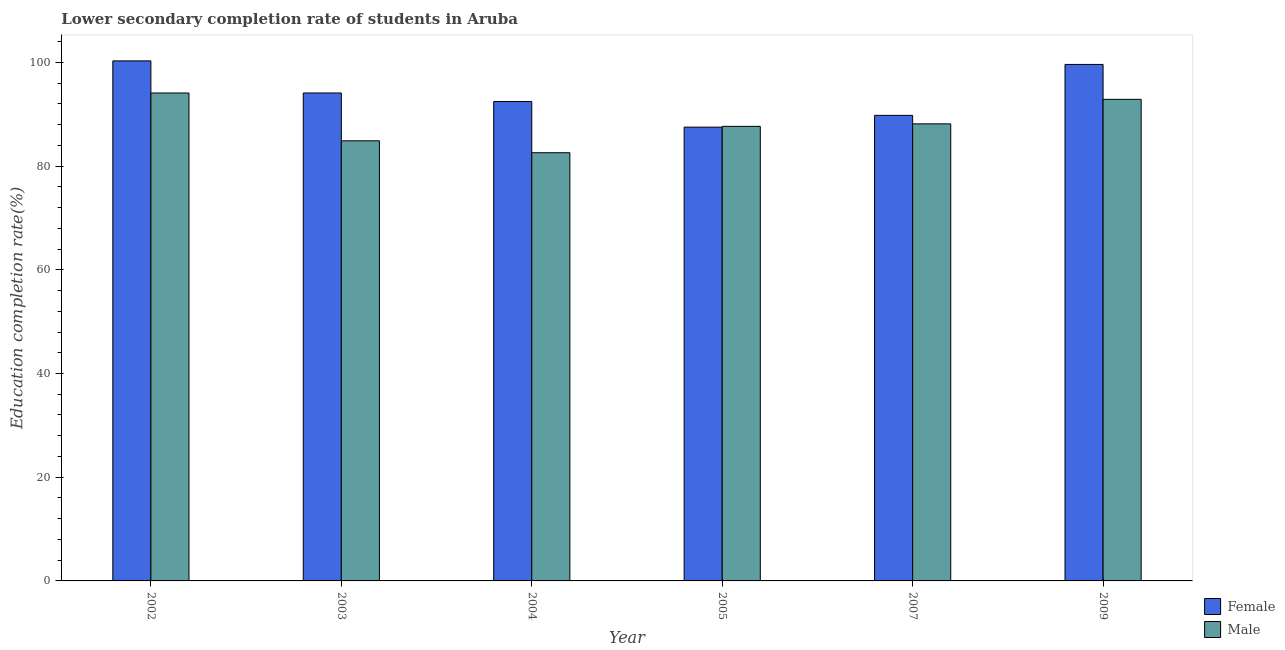How many different coloured bars are there?
Keep it short and to the point. 2. How many groups of bars are there?
Provide a succinct answer. 6. Are the number of bars per tick equal to the number of legend labels?
Provide a succinct answer. Yes. What is the education completion rate of female students in 2004?
Ensure brevity in your answer.  92.45. Across all years, what is the maximum education completion rate of female students?
Provide a short and direct response. 100.29. Across all years, what is the minimum education completion rate of male students?
Make the answer very short. 82.58. In which year was the education completion rate of male students maximum?
Your answer should be very brief. 2002. What is the total education completion rate of female students in the graph?
Keep it short and to the point. 563.76. What is the difference between the education completion rate of male students in 2002 and that in 2005?
Provide a short and direct response. 6.43. What is the difference between the education completion rate of male students in 2005 and the education completion rate of female students in 2003?
Ensure brevity in your answer.  2.79. What is the average education completion rate of female students per year?
Provide a short and direct response. 93.96. In the year 2009, what is the difference between the education completion rate of male students and education completion rate of female students?
Ensure brevity in your answer.  0. What is the ratio of the education completion rate of female students in 2003 to that in 2005?
Make the answer very short. 1.08. Is the education completion rate of female students in 2004 less than that in 2007?
Ensure brevity in your answer.  No. Is the difference between the education completion rate of male students in 2004 and 2007 greater than the difference between the education completion rate of female students in 2004 and 2007?
Keep it short and to the point. No. What is the difference between the highest and the second highest education completion rate of female students?
Your answer should be very brief. 0.69. What is the difference between the highest and the lowest education completion rate of female students?
Your response must be concise. 12.78. Is the sum of the education completion rate of male students in 2004 and 2005 greater than the maximum education completion rate of female students across all years?
Your answer should be compact. Yes. How many bars are there?
Your response must be concise. 12. Are all the bars in the graph horizontal?
Your response must be concise. No. Are the values on the major ticks of Y-axis written in scientific E-notation?
Your response must be concise. No. Where does the legend appear in the graph?
Offer a very short reply. Bottom right. What is the title of the graph?
Provide a succinct answer. Lower secondary completion rate of students in Aruba. What is the label or title of the Y-axis?
Provide a succinct answer. Education completion rate(%). What is the Education completion rate(%) in Female in 2002?
Provide a succinct answer. 100.29. What is the Education completion rate(%) of Male in 2002?
Offer a very short reply. 94.1. What is the Education completion rate(%) of Female in 2003?
Provide a succinct answer. 94.1. What is the Education completion rate(%) in Male in 2003?
Your answer should be very brief. 84.88. What is the Education completion rate(%) in Female in 2004?
Offer a very short reply. 92.45. What is the Education completion rate(%) of Male in 2004?
Provide a succinct answer. 82.58. What is the Education completion rate(%) of Female in 2005?
Give a very brief answer. 87.52. What is the Education completion rate(%) of Male in 2005?
Make the answer very short. 87.67. What is the Education completion rate(%) of Female in 2007?
Provide a short and direct response. 89.79. What is the Education completion rate(%) of Male in 2007?
Provide a succinct answer. 88.15. What is the Education completion rate(%) in Female in 2009?
Provide a short and direct response. 99.61. What is the Education completion rate(%) in Male in 2009?
Give a very brief answer. 92.88. Across all years, what is the maximum Education completion rate(%) in Female?
Offer a very short reply. 100.29. Across all years, what is the maximum Education completion rate(%) of Male?
Your answer should be very brief. 94.1. Across all years, what is the minimum Education completion rate(%) of Female?
Offer a terse response. 87.52. Across all years, what is the minimum Education completion rate(%) of Male?
Your answer should be compact. 82.58. What is the total Education completion rate(%) of Female in the graph?
Offer a very short reply. 563.75. What is the total Education completion rate(%) of Male in the graph?
Offer a very short reply. 530.25. What is the difference between the Education completion rate(%) of Female in 2002 and that in 2003?
Provide a succinct answer. 6.19. What is the difference between the Education completion rate(%) in Male in 2002 and that in 2003?
Provide a short and direct response. 9.22. What is the difference between the Education completion rate(%) of Female in 2002 and that in 2004?
Make the answer very short. 7.84. What is the difference between the Education completion rate(%) in Male in 2002 and that in 2004?
Your response must be concise. 11.52. What is the difference between the Education completion rate(%) in Female in 2002 and that in 2005?
Keep it short and to the point. 12.78. What is the difference between the Education completion rate(%) of Male in 2002 and that in 2005?
Give a very brief answer. 6.43. What is the difference between the Education completion rate(%) in Female in 2002 and that in 2007?
Provide a short and direct response. 10.51. What is the difference between the Education completion rate(%) of Male in 2002 and that in 2007?
Make the answer very short. 5.95. What is the difference between the Education completion rate(%) in Female in 2002 and that in 2009?
Provide a short and direct response. 0.69. What is the difference between the Education completion rate(%) in Male in 2002 and that in 2009?
Your answer should be very brief. 1.23. What is the difference between the Education completion rate(%) of Female in 2003 and that in 2004?
Your answer should be very brief. 1.65. What is the difference between the Education completion rate(%) of Male in 2003 and that in 2004?
Provide a succinct answer. 2.3. What is the difference between the Education completion rate(%) in Female in 2003 and that in 2005?
Give a very brief answer. 6.58. What is the difference between the Education completion rate(%) of Male in 2003 and that in 2005?
Ensure brevity in your answer.  -2.79. What is the difference between the Education completion rate(%) of Female in 2003 and that in 2007?
Make the answer very short. 4.32. What is the difference between the Education completion rate(%) of Male in 2003 and that in 2007?
Your answer should be compact. -3.27. What is the difference between the Education completion rate(%) in Female in 2003 and that in 2009?
Offer a terse response. -5.51. What is the difference between the Education completion rate(%) in Male in 2003 and that in 2009?
Provide a short and direct response. -8. What is the difference between the Education completion rate(%) of Female in 2004 and that in 2005?
Your answer should be compact. 4.94. What is the difference between the Education completion rate(%) in Male in 2004 and that in 2005?
Make the answer very short. -5.09. What is the difference between the Education completion rate(%) in Female in 2004 and that in 2007?
Keep it short and to the point. 2.67. What is the difference between the Education completion rate(%) in Male in 2004 and that in 2007?
Provide a succinct answer. -5.57. What is the difference between the Education completion rate(%) of Female in 2004 and that in 2009?
Provide a short and direct response. -7.15. What is the difference between the Education completion rate(%) of Male in 2004 and that in 2009?
Give a very brief answer. -10.3. What is the difference between the Education completion rate(%) of Female in 2005 and that in 2007?
Make the answer very short. -2.27. What is the difference between the Education completion rate(%) of Male in 2005 and that in 2007?
Make the answer very short. -0.48. What is the difference between the Education completion rate(%) in Female in 2005 and that in 2009?
Give a very brief answer. -12.09. What is the difference between the Education completion rate(%) in Male in 2005 and that in 2009?
Your response must be concise. -5.21. What is the difference between the Education completion rate(%) in Female in 2007 and that in 2009?
Provide a succinct answer. -9.82. What is the difference between the Education completion rate(%) of Male in 2007 and that in 2009?
Provide a short and direct response. -4.73. What is the difference between the Education completion rate(%) of Female in 2002 and the Education completion rate(%) of Male in 2003?
Keep it short and to the point. 15.41. What is the difference between the Education completion rate(%) of Female in 2002 and the Education completion rate(%) of Male in 2004?
Offer a terse response. 17.71. What is the difference between the Education completion rate(%) of Female in 2002 and the Education completion rate(%) of Male in 2005?
Make the answer very short. 12.63. What is the difference between the Education completion rate(%) in Female in 2002 and the Education completion rate(%) in Male in 2007?
Offer a very short reply. 12.15. What is the difference between the Education completion rate(%) of Female in 2002 and the Education completion rate(%) of Male in 2009?
Your answer should be compact. 7.42. What is the difference between the Education completion rate(%) of Female in 2003 and the Education completion rate(%) of Male in 2004?
Provide a short and direct response. 11.52. What is the difference between the Education completion rate(%) in Female in 2003 and the Education completion rate(%) in Male in 2005?
Offer a very short reply. 6.44. What is the difference between the Education completion rate(%) of Female in 2003 and the Education completion rate(%) of Male in 2007?
Offer a very short reply. 5.95. What is the difference between the Education completion rate(%) in Female in 2003 and the Education completion rate(%) in Male in 2009?
Your response must be concise. 1.23. What is the difference between the Education completion rate(%) in Female in 2004 and the Education completion rate(%) in Male in 2005?
Provide a short and direct response. 4.79. What is the difference between the Education completion rate(%) of Female in 2004 and the Education completion rate(%) of Male in 2007?
Offer a terse response. 4.31. What is the difference between the Education completion rate(%) in Female in 2004 and the Education completion rate(%) in Male in 2009?
Offer a terse response. -0.42. What is the difference between the Education completion rate(%) in Female in 2005 and the Education completion rate(%) in Male in 2007?
Give a very brief answer. -0.63. What is the difference between the Education completion rate(%) of Female in 2005 and the Education completion rate(%) of Male in 2009?
Ensure brevity in your answer.  -5.36. What is the difference between the Education completion rate(%) in Female in 2007 and the Education completion rate(%) in Male in 2009?
Ensure brevity in your answer.  -3.09. What is the average Education completion rate(%) of Female per year?
Offer a terse response. 93.96. What is the average Education completion rate(%) of Male per year?
Keep it short and to the point. 88.37. In the year 2002, what is the difference between the Education completion rate(%) in Female and Education completion rate(%) in Male?
Provide a short and direct response. 6.19. In the year 2003, what is the difference between the Education completion rate(%) of Female and Education completion rate(%) of Male?
Ensure brevity in your answer.  9.22. In the year 2004, what is the difference between the Education completion rate(%) in Female and Education completion rate(%) in Male?
Provide a succinct answer. 9.87. In the year 2005, what is the difference between the Education completion rate(%) of Female and Education completion rate(%) of Male?
Your response must be concise. -0.15. In the year 2007, what is the difference between the Education completion rate(%) in Female and Education completion rate(%) in Male?
Offer a terse response. 1.64. In the year 2009, what is the difference between the Education completion rate(%) of Female and Education completion rate(%) of Male?
Provide a succinct answer. 6.73. What is the ratio of the Education completion rate(%) in Female in 2002 to that in 2003?
Your answer should be very brief. 1.07. What is the ratio of the Education completion rate(%) of Male in 2002 to that in 2003?
Make the answer very short. 1.11. What is the ratio of the Education completion rate(%) in Female in 2002 to that in 2004?
Your answer should be compact. 1.08. What is the ratio of the Education completion rate(%) in Male in 2002 to that in 2004?
Your response must be concise. 1.14. What is the ratio of the Education completion rate(%) of Female in 2002 to that in 2005?
Your answer should be compact. 1.15. What is the ratio of the Education completion rate(%) of Male in 2002 to that in 2005?
Your response must be concise. 1.07. What is the ratio of the Education completion rate(%) of Female in 2002 to that in 2007?
Provide a short and direct response. 1.12. What is the ratio of the Education completion rate(%) in Male in 2002 to that in 2007?
Offer a terse response. 1.07. What is the ratio of the Education completion rate(%) in Female in 2002 to that in 2009?
Keep it short and to the point. 1.01. What is the ratio of the Education completion rate(%) of Male in 2002 to that in 2009?
Keep it short and to the point. 1.01. What is the ratio of the Education completion rate(%) in Female in 2003 to that in 2004?
Offer a terse response. 1.02. What is the ratio of the Education completion rate(%) in Male in 2003 to that in 2004?
Provide a short and direct response. 1.03. What is the ratio of the Education completion rate(%) of Female in 2003 to that in 2005?
Provide a succinct answer. 1.08. What is the ratio of the Education completion rate(%) in Male in 2003 to that in 2005?
Make the answer very short. 0.97. What is the ratio of the Education completion rate(%) in Female in 2003 to that in 2007?
Make the answer very short. 1.05. What is the ratio of the Education completion rate(%) of Male in 2003 to that in 2007?
Provide a short and direct response. 0.96. What is the ratio of the Education completion rate(%) of Female in 2003 to that in 2009?
Your answer should be very brief. 0.94. What is the ratio of the Education completion rate(%) in Male in 2003 to that in 2009?
Your response must be concise. 0.91. What is the ratio of the Education completion rate(%) in Female in 2004 to that in 2005?
Provide a short and direct response. 1.06. What is the ratio of the Education completion rate(%) in Male in 2004 to that in 2005?
Provide a succinct answer. 0.94. What is the ratio of the Education completion rate(%) in Female in 2004 to that in 2007?
Provide a short and direct response. 1.03. What is the ratio of the Education completion rate(%) of Male in 2004 to that in 2007?
Ensure brevity in your answer.  0.94. What is the ratio of the Education completion rate(%) of Female in 2004 to that in 2009?
Offer a terse response. 0.93. What is the ratio of the Education completion rate(%) in Male in 2004 to that in 2009?
Give a very brief answer. 0.89. What is the ratio of the Education completion rate(%) of Female in 2005 to that in 2007?
Offer a terse response. 0.97. What is the ratio of the Education completion rate(%) in Male in 2005 to that in 2007?
Provide a short and direct response. 0.99. What is the ratio of the Education completion rate(%) in Female in 2005 to that in 2009?
Keep it short and to the point. 0.88. What is the ratio of the Education completion rate(%) in Male in 2005 to that in 2009?
Provide a succinct answer. 0.94. What is the ratio of the Education completion rate(%) of Female in 2007 to that in 2009?
Keep it short and to the point. 0.9. What is the ratio of the Education completion rate(%) of Male in 2007 to that in 2009?
Your answer should be compact. 0.95. What is the difference between the highest and the second highest Education completion rate(%) in Female?
Keep it short and to the point. 0.69. What is the difference between the highest and the second highest Education completion rate(%) of Male?
Your answer should be very brief. 1.23. What is the difference between the highest and the lowest Education completion rate(%) in Female?
Ensure brevity in your answer.  12.78. What is the difference between the highest and the lowest Education completion rate(%) in Male?
Make the answer very short. 11.52. 